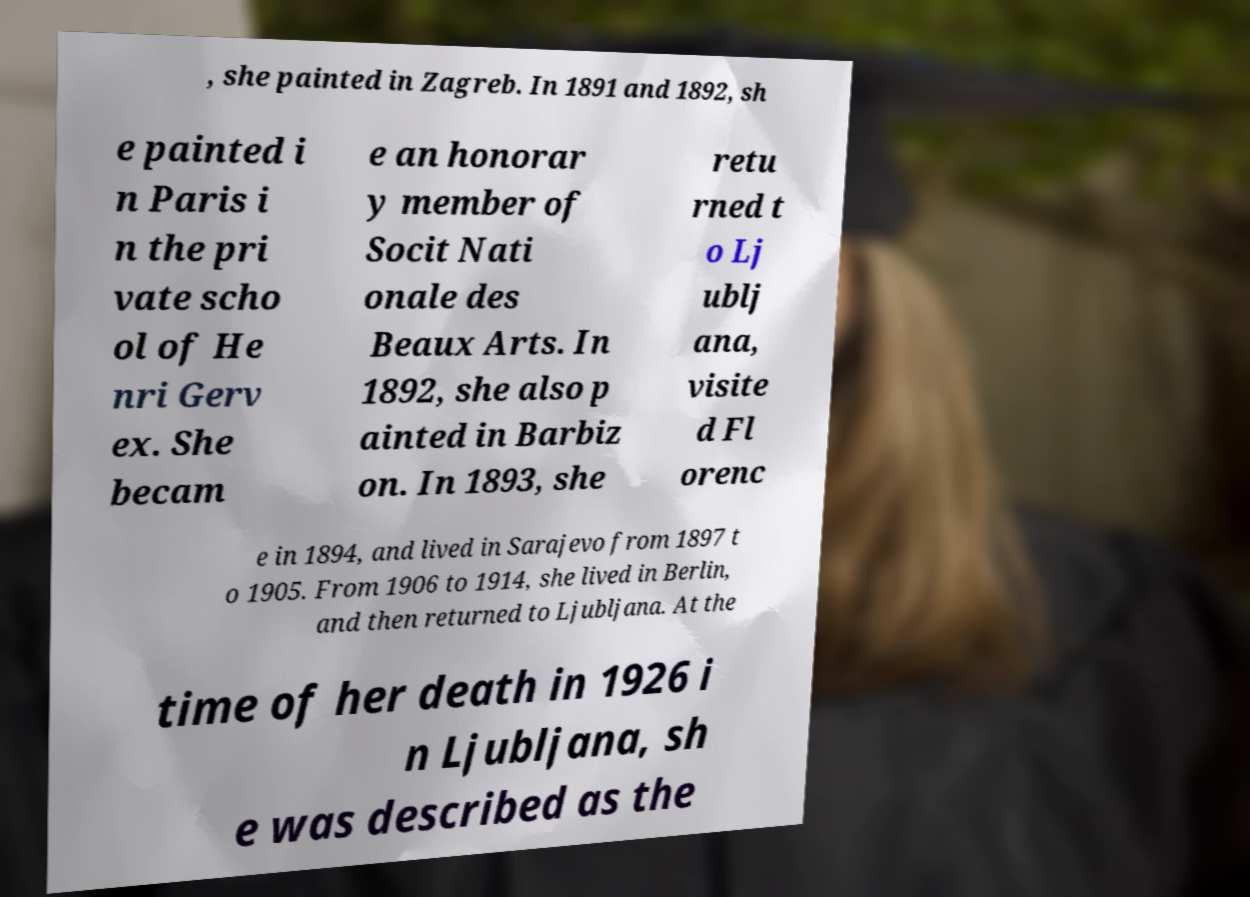I need the written content from this picture converted into text. Can you do that? , she painted in Zagreb. In 1891 and 1892, sh e painted i n Paris i n the pri vate scho ol of He nri Gerv ex. She becam e an honorar y member of Socit Nati onale des Beaux Arts. In 1892, she also p ainted in Barbiz on. In 1893, she retu rned t o Lj ublj ana, visite d Fl orenc e in 1894, and lived in Sarajevo from 1897 t o 1905. From 1906 to 1914, she lived in Berlin, and then returned to Ljubljana. At the time of her death in 1926 i n Ljubljana, sh e was described as the 